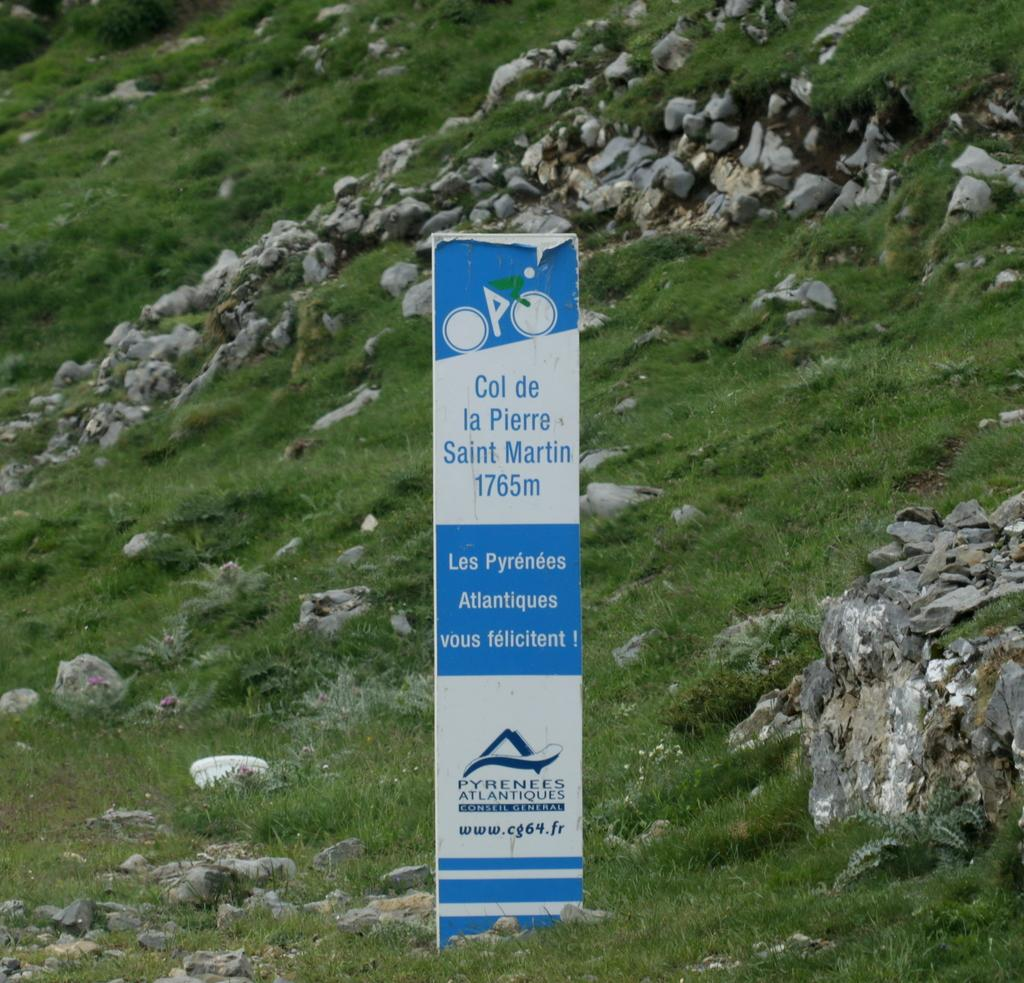What is located at the front of the image? There is a board in the front of the image. What can be seen on the board? Something is written on the board. What type of natural environment is visible in the background of the image? There are rocks and grass in the background of the image. Where is the kettle placed in the image? There is no kettle present in the image. What type of paste is being used to write on the board? There is no information about the type of paste used to write on the board, as it is not mentioned in the facts. 